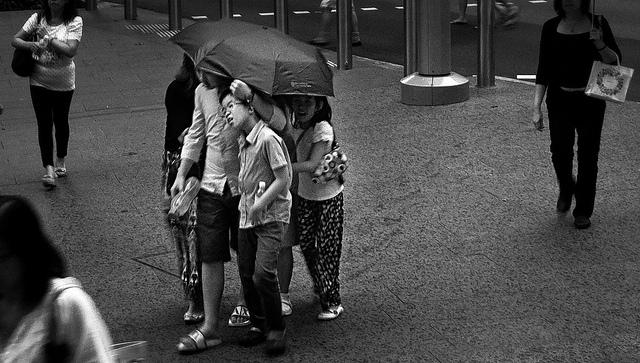What number is closest to how many people are under the middle umbrella? four 